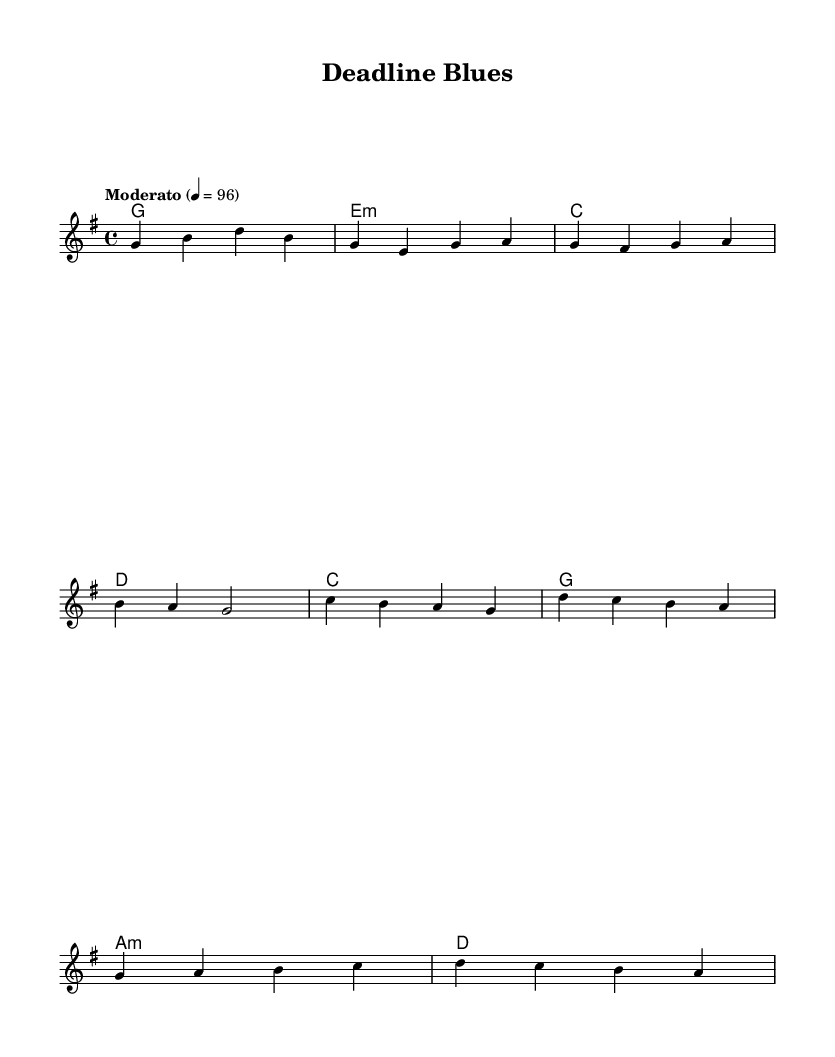What is the key signature of this music? The key signature indicated at the beginning specifies G major, which has one sharp (F#).
Answer: G major What is the time signature of this piece? The time signature shown in the sheet music is 4/4, which means there are four beats in each measure and the quarter note gets one beat.
Answer: 4/4 What is the tempo marking for this composition? The tempo marking is "Moderato" and is set to 96 beats per minute, indicating a moderate speed for the music.
Answer: Moderato, 96 What is the first note of the melody in the verse? The first note of the melody in the verse is G, which is located on the second line of the treble clef.
Answer: G How many measures are in the chorus? By counting the measures notated, there are four distinct measures in the chorus section of the music.
Answer: 4 What is the emotional theme expressed in the lyrics? The lyrics express a tension between creativity and the constraints of time, emphasizing the struggle of balancing artistic inspiration with deadlines.
Answer: Balancing act What kind of chords are predominantly used in the verse? The chords in the verse primarily consist of major and minor triads, specifically G major, E minor, C major, and D major, typical of country rock.
Answer: Major and minor triads 